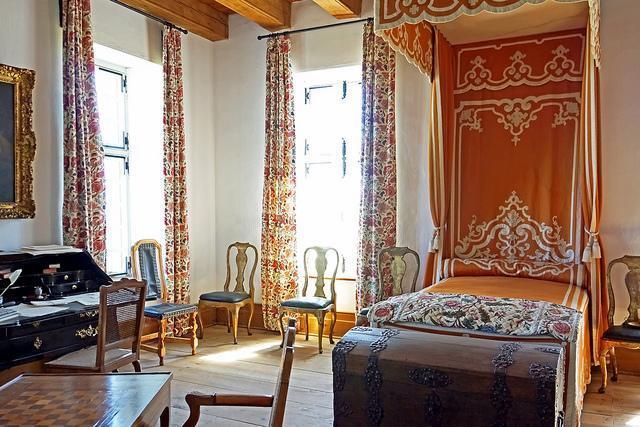How many chairs are there?
Give a very brief answer. 7. How many chairs are in the picture?
Give a very brief answer. 5. How many trains have lights on?
Give a very brief answer. 0. 